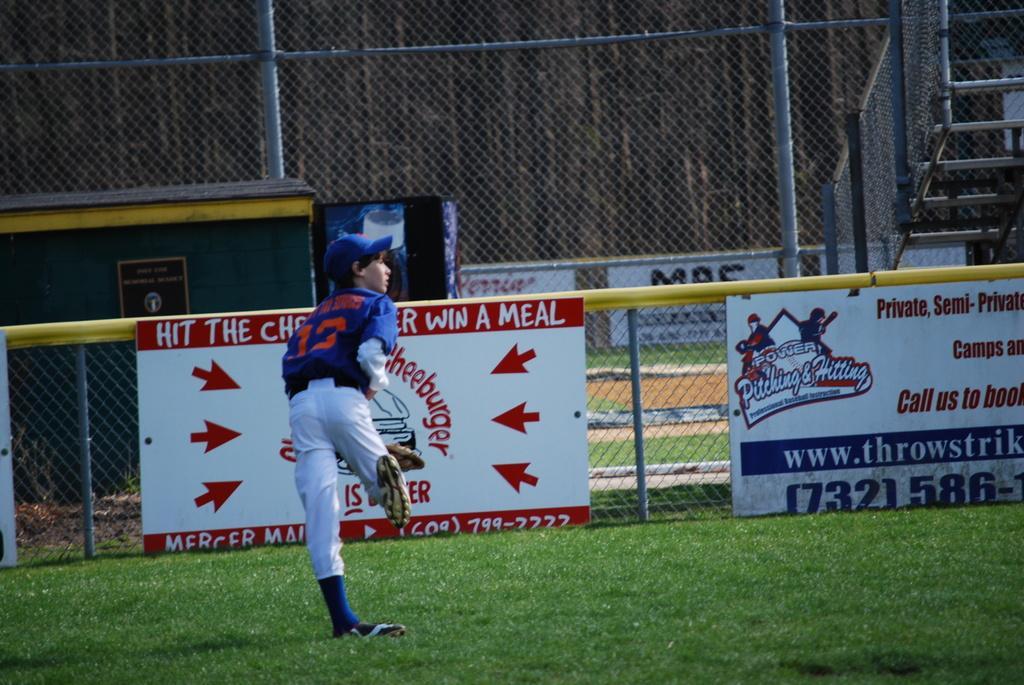Could you give a brief overview of what you see in this image? In this image we can see a boy is standing on the grassy land. In the background, we can see banners, fence, board, mesh and stairs. 